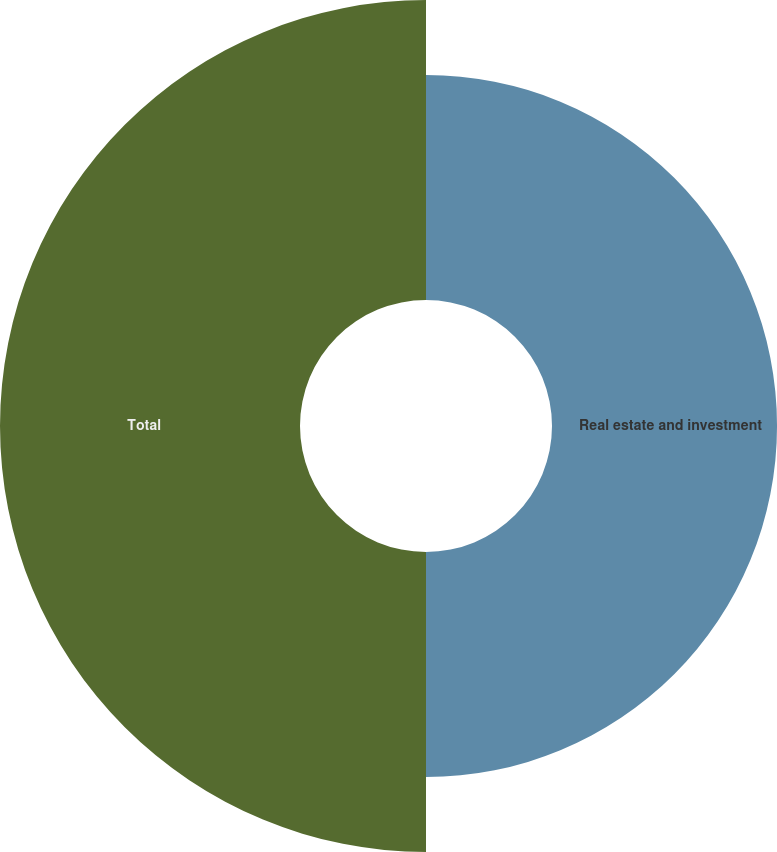Convert chart. <chart><loc_0><loc_0><loc_500><loc_500><pie_chart><fcel>Real estate and investment<fcel>Total<nl><fcel>42.86%<fcel>57.14%<nl></chart> 